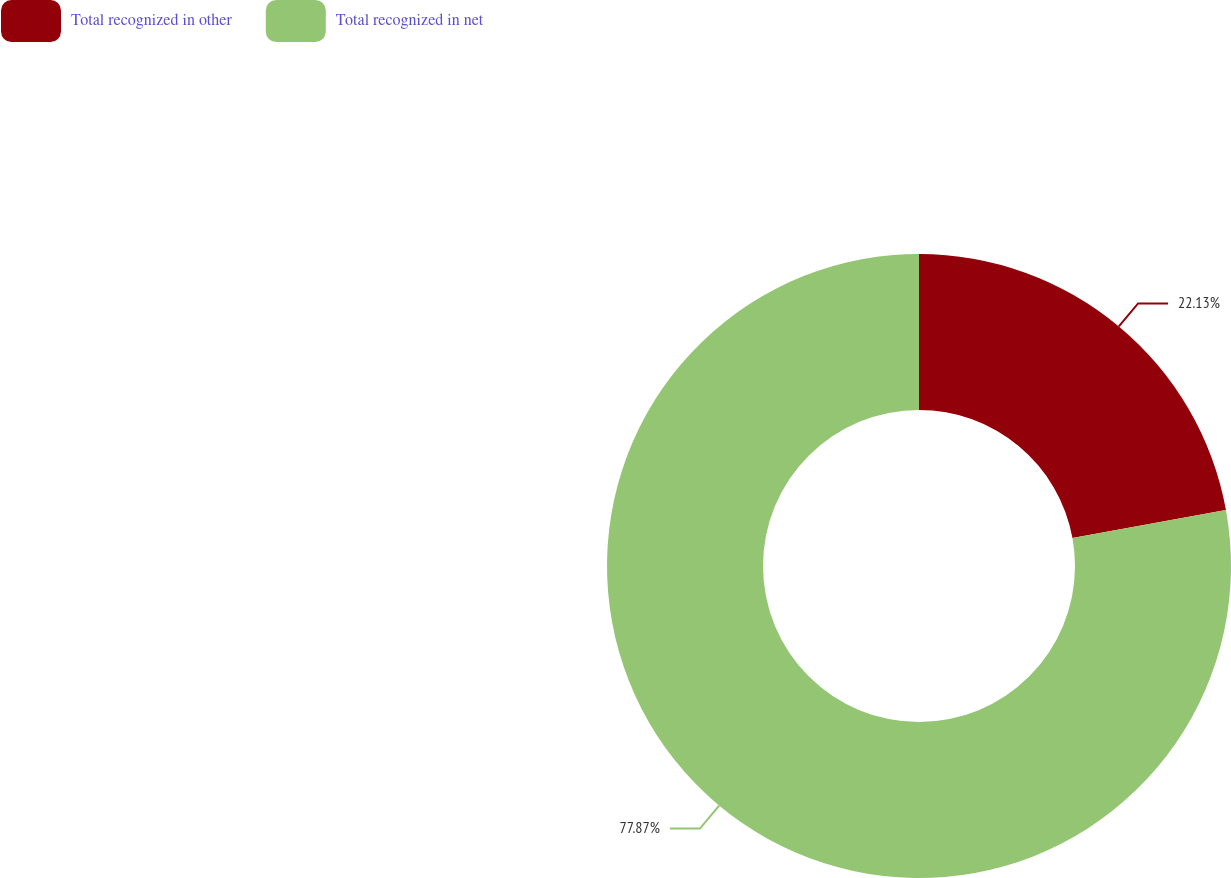Convert chart to OTSL. <chart><loc_0><loc_0><loc_500><loc_500><pie_chart><fcel>Total recognized in other<fcel>Total recognized in net<nl><fcel>22.13%<fcel>77.87%<nl></chart> 